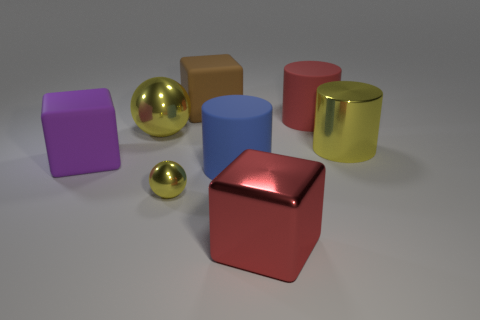There is a cube in front of the large matte cube that is in front of the large matte cylinder right of the red shiny block; what color is it?
Give a very brief answer. Red. There is a big purple object; is its shape the same as the yellow metallic thing that is in front of the blue matte object?
Your answer should be compact. No. There is a large thing that is behind the yellow metal cylinder and in front of the big red matte cylinder; what color is it?
Provide a succinct answer. Yellow. Is there another shiny thing that has the same shape as the tiny yellow metallic thing?
Offer a very short reply. Yes. Is the metal cylinder the same color as the small sphere?
Keep it short and to the point. Yes. There is a matte cylinder behind the big yellow shiny cylinder; are there any large matte objects on the left side of it?
Your answer should be compact. Yes. What number of things are either yellow metallic balls to the right of the large ball or large matte things in front of the large red cylinder?
Give a very brief answer. 3. How many objects are either big rubber cylinders or big metallic things in front of the tiny yellow metallic ball?
Your answer should be very brief. 3. How big is the red object that is behind the large purple thing on the left side of the yellow ball that is in front of the purple object?
Your response must be concise. Large. There is a brown block that is the same size as the blue thing; what is its material?
Give a very brief answer. Rubber. 